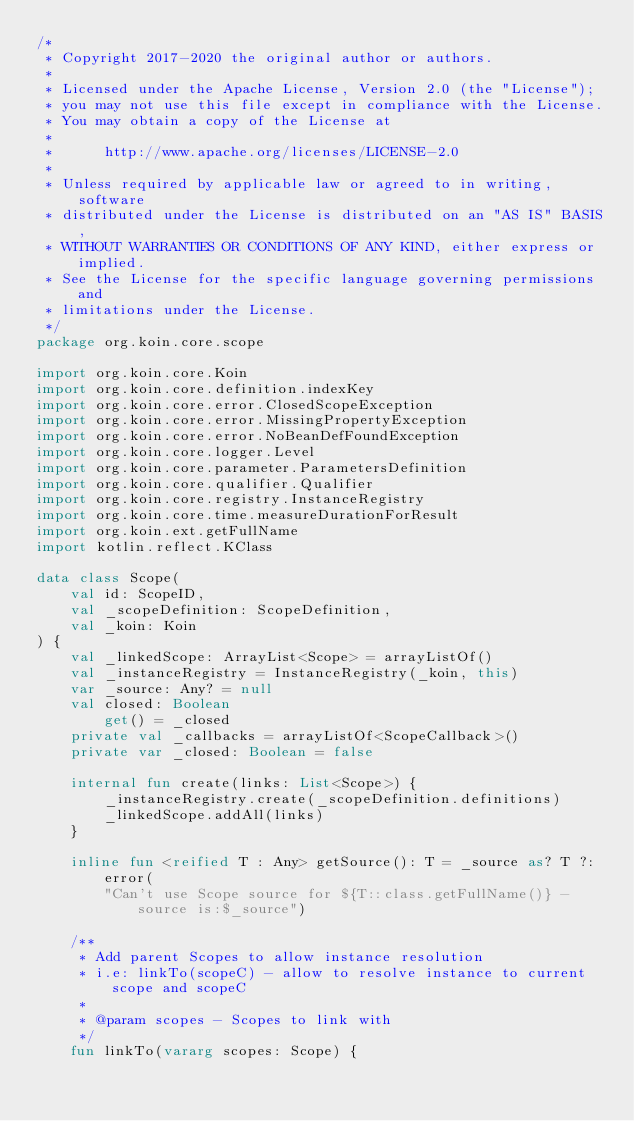Convert code to text. <code><loc_0><loc_0><loc_500><loc_500><_Kotlin_>/*
 * Copyright 2017-2020 the original author or authors.
 *
 * Licensed under the Apache License, Version 2.0 (the "License");
 * you may not use this file except in compliance with the License.
 * You may obtain a copy of the License at
 *
 *      http://www.apache.org/licenses/LICENSE-2.0
 *
 * Unless required by applicable law or agreed to in writing, software
 * distributed under the License is distributed on an "AS IS" BASIS,
 * WITHOUT WARRANTIES OR CONDITIONS OF ANY KIND, either express or implied.
 * See the License for the specific language governing permissions and
 * limitations under the License.
 */
package org.koin.core.scope

import org.koin.core.Koin
import org.koin.core.definition.indexKey
import org.koin.core.error.ClosedScopeException
import org.koin.core.error.MissingPropertyException
import org.koin.core.error.NoBeanDefFoundException
import org.koin.core.logger.Level
import org.koin.core.parameter.ParametersDefinition
import org.koin.core.qualifier.Qualifier
import org.koin.core.registry.InstanceRegistry
import org.koin.core.time.measureDurationForResult
import org.koin.ext.getFullName
import kotlin.reflect.KClass

data class Scope(
    val id: ScopeID,
    val _scopeDefinition: ScopeDefinition,
    val _koin: Koin
) {
    val _linkedScope: ArrayList<Scope> = arrayListOf()
    val _instanceRegistry = InstanceRegistry(_koin, this)
    var _source: Any? = null
    val closed: Boolean
        get() = _closed
    private val _callbacks = arrayListOf<ScopeCallback>()
    private var _closed: Boolean = false

    internal fun create(links: List<Scope>) {
        _instanceRegistry.create(_scopeDefinition.definitions)
        _linkedScope.addAll(links)
    }

    inline fun <reified T : Any> getSource(): T = _source as? T ?: error(
        "Can't use Scope source for ${T::class.getFullName()} - source is:$_source")

    /**
     * Add parent Scopes to allow instance resolution
     * i.e: linkTo(scopeC) - allow to resolve instance to current scope and scopeC
     *
     * @param scopes - Scopes to link with
     */
    fun linkTo(vararg scopes: Scope) {</code> 